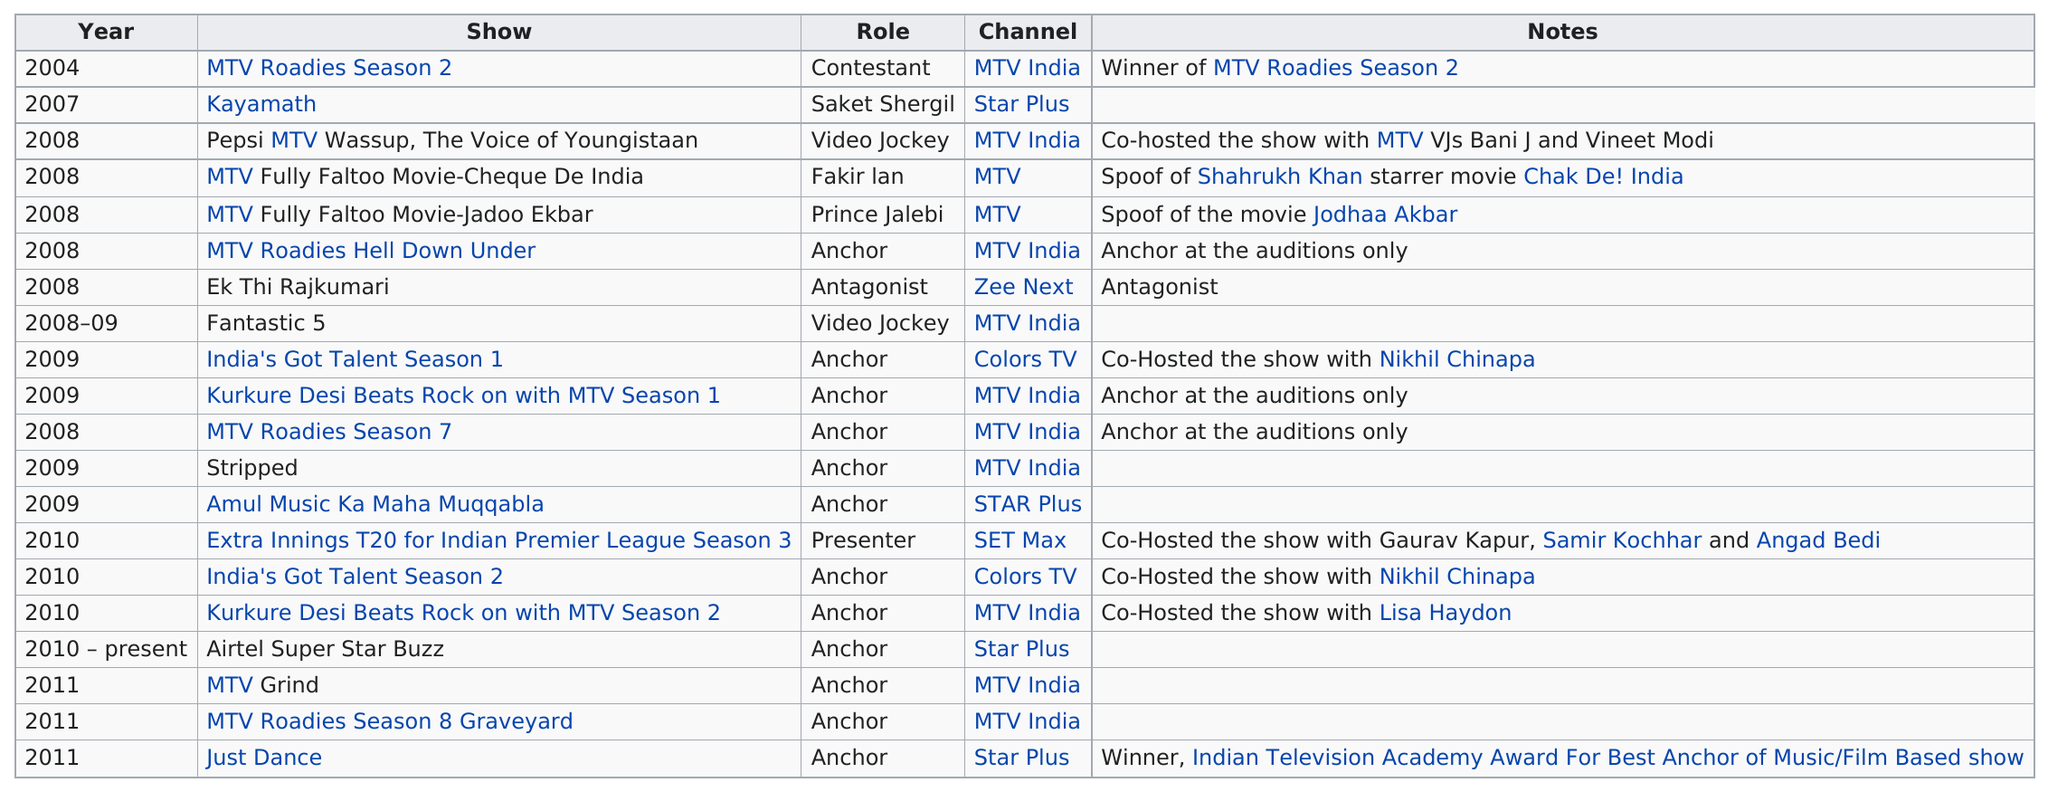Indicate a few pertinent items in this graphic. What is the last show listed? It is Just Dance.. The actor appeared on "India's Got Talent Season 1" after "The Fantastic 5. The first television role of this actor was that of a contestant. This actor had 13 roles before 2010. I attended two excellent video jockey shows, one named 'Fantastic 5' and the other named 'Pepsi MTV Wassup, The Voice of Youngistaan'. 